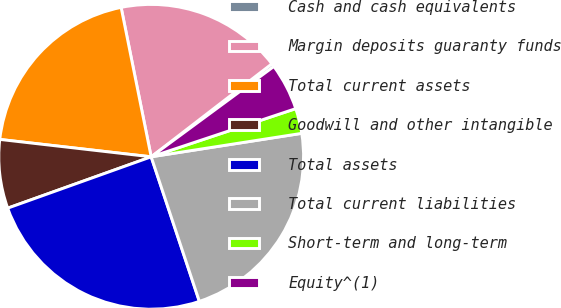<chart> <loc_0><loc_0><loc_500><loc_500><pie_chart><fcel>Cash and cash equivalents<fcel>Margin deposits guaranty funds<fcel>Total current assets<fcel>Goodwill and other intangible<fcel>Total assets<fcel>Total current liabilities<fcel>Short-term and long-term<fcel>Equity^(1)<nl><fcel>0.35%<fcel>17.71%<fcel>20.02%<fcel>7.29%<fcel>24.65%<fcel>22.34%<fcel>2.66%<fcel>4.98%<nl></chart> 